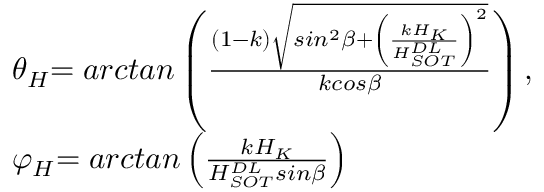Convert formula to latex. <formula><loc_0><loc_0><loc_500><loc_500>\begin{array} { l l } { { \theta } _ { H } { = a r c t a n } \left ( \frac { \left ( 1 - k \right ) \sqrt { \sin ^ { 2 } \beta + { \left ( \frac { k H _ { K } } { H _ { S O T } ^ { D L } } \right ) } ^ { 2 } } } { k \cos \beta } \right ) , } \\ { { \varphi } _ { H } { = a r c t a n } \left ( \frac { k H _ { K } } { H _ { S O T } ^ { D L } \sin \beta } \right ) } \end{array}</formula> 